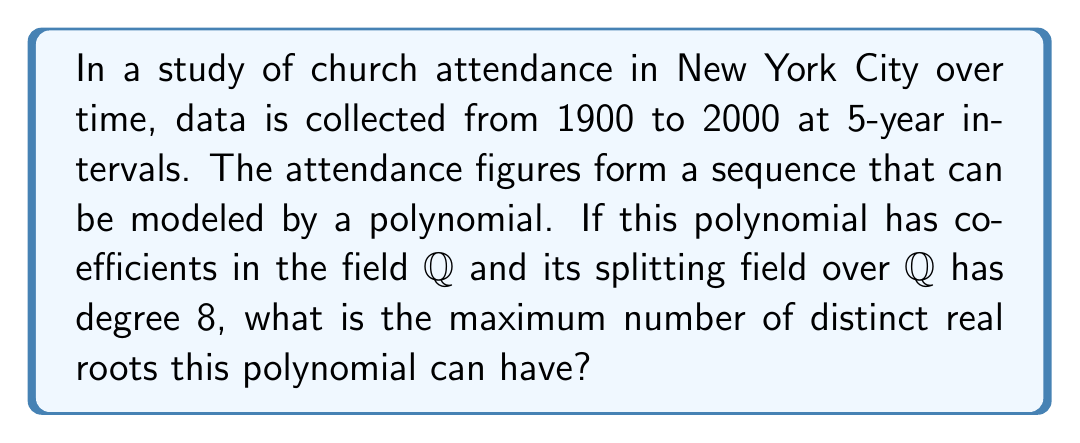Help me with this question. Let's approach this step-by-step:

1) First, we need to understand what the question is asking. We're dealing with a polynomial that models church attendance over time, and we're told about its splitting field.

2) The splitting field of a polynomial is the smallest field extension that contains all the roots of the polynomial.

3) We're given that the degree of the splitting field over $\mathbb{Q}$ is 8. This means:

   $$[\mathbb{Q}(\alpha_1, \alpha_2, ..., \alpha_n) : \mathbb{Q}] = 8$$

   where $\alpha_1, \alpha_2, ..., \alpha_n$ are all the roots of the polynomial.

4) The degree of the splitting field is always a multiple of the degree of each irreducible factor of the polynomial over $\mathbb{Q}$.

5) The possible degrees of irreducible polynomials over $\mathbb{Q}$ that could give a splitting field of degree 8 are:
   - One irreducible polynomial of degree 8
   - Two irreducible polynomials of degree 4
   - One irreducible polynomial of degree 4 and two of degree 2
   - Four irreducible polynomials of degree 2

6) Real roots always come from factors of degree 1 or 2 over $\mathbb{Q}$.

7) Therefore, the maximum number of real roots would occur in the case where we have four irreducible polynomials of degree 2.

8) Each quadratic polynomial can have at most 2 real roots.

9) Thus, the maximum number of real roots is 4 * 2 = 8.
Answer: 8 